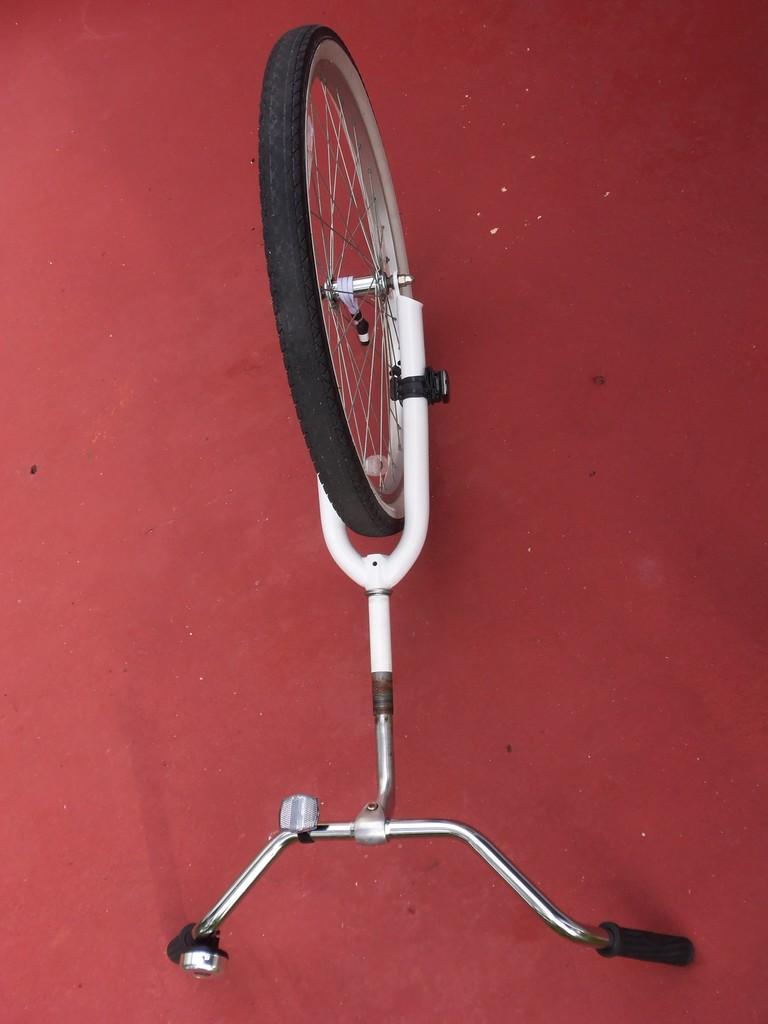What is the main object in the image? There is a bicycle in the image. How many wheels does the bicycle have? The bicycle has one wheel. Where is the wheel located in relation to the rest of the bicycle? The wheel is fitting on a platform. What type of eggnog can be seen on the platform of the bicycle in the image? There is no eggnog present in the image; it features a bicycle with one wheel fitting on a platform. 